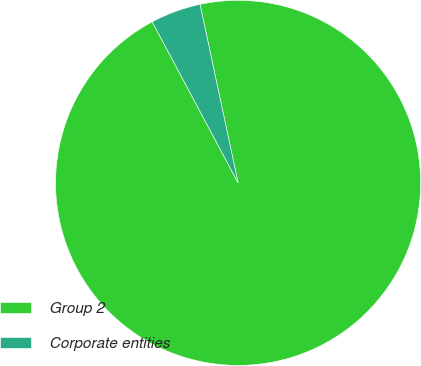Convert chart. <chart><loc_0><loc_0><loc_500><loc_500><pie_chart><fcel>Group 2<fcel>Corporate entities<nl><fcel>95.55%<fcel>4.45%<nl></chart> 